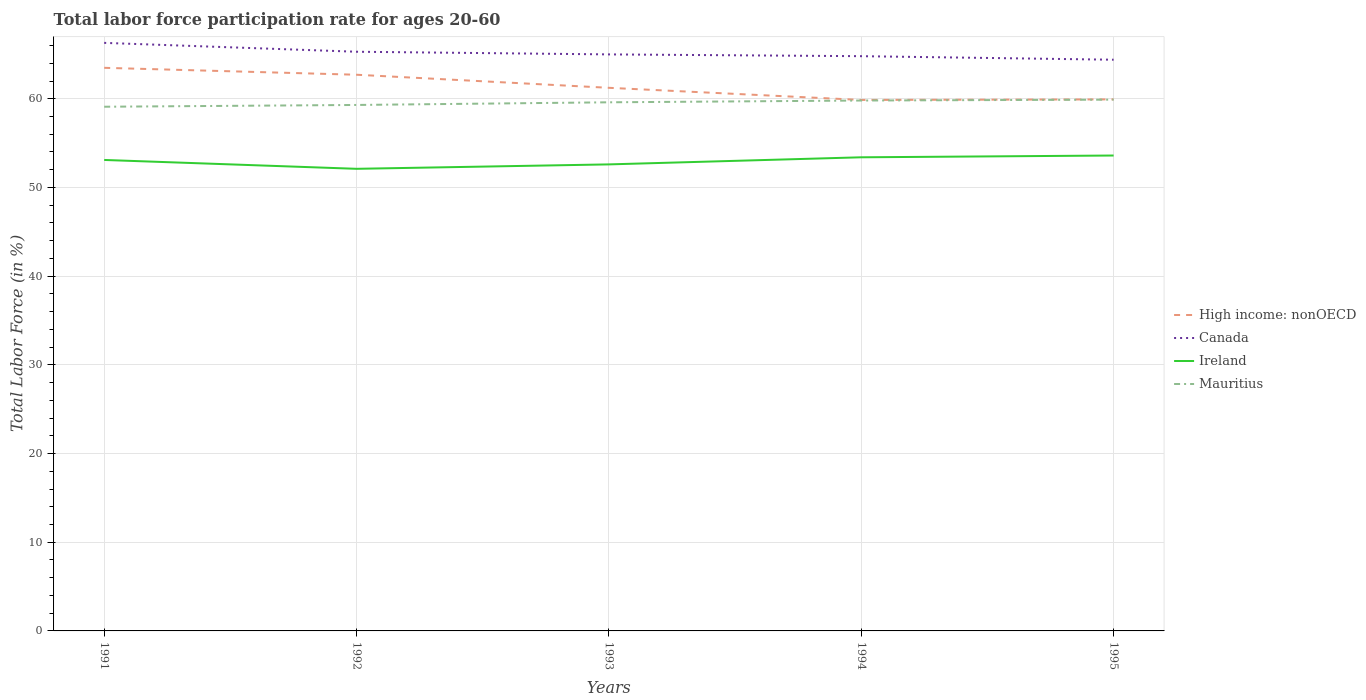How many different coloured lines are there?
Your answer should be compact. 4. Does the line corresponding to Mauritius intersect with the line corresponding to Ireland?
Offer a very short reply. No. Across all years, what is the maximum labor force participation rate in Canada?
Provide a short and direct response. 64.4. What is the total labor force participation rate in Mauritius in the graph?
Make the answer very short. -0.8. What is the difference between the highest and the second highest labor force participation rate in Canada?
Offer a terse response. 1.9. Is the labor force participation rate in Canada strictly greater than the labor force participation rate in Ireland over the years?
Your answer should be very brief. No. How many lines are there?
Keep it short and to the point. 4. What is the difference between two consecutive major ticks on the Y-axis?
Ensure brevity in your answer.  10. What is the title of the graph?
Provide a short and direct response. Total labor force participation rate for ages 20-60. What is the label or title of the X-axis?
Your response must be concise. Years. What is the label or title of the Y-axis?
Make the answer very short. Total Labor Force (in %). What is the Total Labor Force (in %) of High income: nonOECD in 1991?
Provide a succinct answer. 63.49. What is the Total Labor Force (in %) in Canada in 1991?
Make the answer very short. 66.3. What is the Total Labor Force (in %) in Ireland in 1991?
Your answer should be very brief. 53.1. What is the Total Labor Force (in %) in Mauritius in 1991?
Provide a short and direct response. 59.1. What is the Total Labor Force (in %) of High income: nonOECD in 1992?
Give a very brief answer. 62.71. What is the Total Labor Force (in %) in Canada in 1992?
Your response must be concise. 65.3. What is the Total Labor Force (in %) of Ireland in 1992?
Give a very brief answer. 52.1. What is the Total Labor Force (in %) in Mauritius in 1992?
Your response must be concise. 59.3. What is the Total Labor Force (in %) in High income: nonOECD in 1993?
Keep it short and to the point. 61.23. What is the Total Labor Force (in %) in Ireland in 1993?
Your answer should be compact. 52.6. What is the Total Labor Force (in %) of Mauritius in 1993?
Give a very brief answer. 59.6. What is the Total Labor Force (in %) of High income: nonOECD in 1994?
Your answer should be very brief. 59.87. What is the Total Labor Force (in %) in Canada in 1994?
Give a very brief answer. 64.8. What is the Total Labor Force (in %) in Ireland in 1994?
Provide a short and direct response. 53.4. What is the Total Labor Force (in %) of Mauritius in 1994?
Ensure brevity in your answer.  59.8. What is the Total Labor Force (in %) in High income: nonOECD in 1995?
Your answer should be very brief. 59.93. What is the Total Labor Force (in %) in Canada in 1995?
Provide a short and direct response. 64.4. What is the Total Labor Force (in %) of Ireland in 1995?
Keep it short and to the point. 53.6. What is the Total Labor Force (in %) in Mauritius in 1995?
Give a very brief answer. 59.9. Across all years, what is the maximum Total Labor Force (in %) in High income: nonOECD?
Make the answer very short. 63.49. Across all years, what is the maximum Total Labor Force (in %) of Canada?
Ensure brevity in your answer.  66.3. Across all years, what is the maximum Total Labor Force (in %) in Ireland?
Your response must be concise. 53.6. Across all years, what is the maximum Total Labor Force (in %) of Mauritius?
Your answer should be very brief. 59.9. Across all years, what is the minimum Total Labor Force (in %) of High income: nonOECD?
Make the answer very short. 59.87. Across all years, what is the minimum Total Labor Force (in %) of Canada?
Provide a succinct answer. 64.4. Across all years, what is the minimum Total Labor Force (in %) of Ireland?
Offer a terse response. 52.1. Across all years, what is the minimum Total Labor Force (in %) in Mauritius?
Give a very brief answer. 59.1. What is the total Total Labor Force (in %) of High income: nonOECD in the graph?
Make the answer very short. 307.22. What is the total Total Labor Force (in %) in Canada in the graph?
Offer a terse response. 325.8. What is the total Total Labor Force (in %) of Ireland in the graph?
Make the answer very short. 264.8. What is the total Total Labor Force (in %) in Mauritius in the graph?
Your answer should be very brief. 297.7. What is the difference between the Total Labor Force (in %) of High income: nonOECD in 1991 and that in 1992?
Keep it short and to the point. 0.78. What is the difference between the Total Labor Force (in %) of Canada in 1991 and that in 1992?
Your answer should be very brief. 1. What is the difference between the Total Labor Force (in %) in Ireland in 1991 and that in 1992?
Ensure brevity in your answer.  1. What is the difference between the Total Labor Force (in %) in Mauritius in 1991 and that in 1992?
Your answer should be very brief. -0.2. What is the difference between the Total Labor Force (in %) of High income: nonOECD in 1991 and that in 1993?
Provide a succinct answer. 2.25. What is the difference between the Total Labor Force (in %) in Ireland in 1991 and that in 1993?
Provide a short and direct response. 0.5. What is the difference between the Total Labor Force (in %) of Mauritius in 1991 and that in 1993?
Your answer should be compact. -0.5. What is the difference between the Total Labor Force (in %) in High income: nonOECD in 1991 and that in 1994?
Provide a succinct answer. 3.62. What is the difference between the Total Labor Force (in %) in Canada in 1991 and that in 1994?
Provide a short and direct response. 1.5. What is the difference between the Total Labor Force (in %) in Mauritius in 1991 and that in 1994?
Offer a terse response. -0.7. What is the difference between the Total Labor Force (in %) of High income: nonOECD in 1991 and that in 1995?
Provide a short and direct response. 3.56. What is the difference between the Total Labor Force (in %) of Canada in 1991 and that in 1995?
Provide a short and direct response. 1.9. What is the difference between the Total Labor Force (in %) in Ireland in 1991 and that in 1995?
Provide a short and direct response. -0.5. What is the difference between the Total Labor Force (in %) in High income: nonOECD in 1992 and that in 1993?
Your answer should be very brief. 1.47. What is the difference between the Total Labor Force (in %) of Canada in 1992 and that in 1993?
Offer a very short reply. 0.3. What is the difference between the Total Labor Force (in %) in Mauritius in 1992 and that in 1993?
Give a very brief answer. -0.3. What is the difference between the Total Labor Force (in %) of High income: nonOECD in 1992 and that in 1994?
Ensure brevity in your answer.  2.84. What is the difference between the Total Labor Force (in %) of Ireland in 1992 and that in 1994?
Your answer should be very brief. -1.3. What is the difference between the Total Labor Force (in %) in High income: nonOECD in 1992 and that in 1995?
Provide a short and direct response. 2.78. What is the difference between the Total Labor Force (in %) of Canada in 1992 and that in 1995?
Offer a very short reply. 0.9. What is the difference between the Total Labor Force (in %) of Mauritius in 1992 and that in 1995?
Give a very brief answer. -0.6. What is the difference between the Total Labor Force (in %) of High income: nonOECD in 1993 and that in 1994?
Provide a short and direct response. 1.37. What is the difference between the Total Labor Force (in %) in Ireland in 1993 and that in 1994?
Your response must be concise. -0.8. What is the difference between the Total Labor Force (in %) of Mauritius in 1993 and that in 1994?
Keep it short and to the point. -0.2. What is the difference between the Total Labor Force (in %) of High income: nonOECD in 1993 and that in 1995?
Give a very brief answer. 1.3. What is the difference between the Total Labor Force (in %) in Ireland in 1993 and that in 1995?
Your answer should be very brief. -1. What is the difference between the Total Labor Force (in %) of Mauritius in 1993 and that in 1995?
Provide a succinct answer. -0.3. What is the difference between the Total Labor Force (in %) of High income: nonOECD in 1994 and that in 1995?
Give a very brief answer. -0.06. What is the difference between the Total Labor Force (in %) in Mauritius in 1994 and that in 1995?
Keep it short and to the point. -0.1. What is the difference between the Total Labor Force (in %) in High income: nonOECD in 1991 and the Total Labor Force (in %) in Canada in 1992?
Provide a short and direct response. -1.81. What is the difference between the Total Labor Force (in %) in High income: nonOECD in 1991 and the Total Labor Force (in %) in Ireland in 1992?
Provide a short and direct response. 11.39. What is the difference between the Total Labor Force (in %) of High income: nonOECD in 1991 and the Total Labor Force (in %) of Mauritius in 1992?
Ensure brevity in your answer.  4.19. What is the difference between the Total Labor Force (in %) of Canada in 1991 and the Total Labor Force (in %) of Ireland in 1992?
Keep it short and to the point. 14.2. What is the difference between the Total Labor Force (in %) in Canada in 1991 and the Total Labor Force (in %) in Mauritius in 1992?
Offer a very short reply. 7. What is the difference between the Total Labor Force (in %) in High income: nonOECD in 1991 and the Total Labor Force (in %) in Canada in 1993?
Ensure brevity in your answer.  -1.51. What is the difference between the Total Labor Force (in %) in High income: nonOECD in 1991 and the Total Labor Force (in %) in Ireland in 1993?
Your answer should be compact. 10.89. What is the difference between the Total Labor Force (in %) in High income: nonOECD in 1991 and the Total Labor Force (in %) in Mauritius in 1993?
Provide a succinct answer. 3.89. What is the difference between the Total Labor Force (in %) of Canada in 1991 and the Total Labor Force (in %) of Mauritius in 1993?
Offer a very short reply. 6.7. What is the difference between the Total Labor Force (in %) in High income: nonOECD in 1991 and the Total Labor Force (in %) in Canada in 1994?
Your answer should be compact. -1.31. What is the difference between the Total Labor Force (in %) of High income: nonOECD in 1991 and the Total Labor Force (in %) of Ireland in 1994?
Your answer should be compact. 10.09. What is the difference between the Total Labor Force (in %) in High income: nonOECD in 1991 and the Total Labor Force (in %) in Mauritius in 1994?
Give a very brief answer. 3.69. What is the difference between the Total Labor Force (in %) in Canada in 1991 and the Total Labor Force (in %) in Ireland in 1994?
Provide a succinct answer. 12.9. What is the difference between the Total Labor Force (in %) in Canada in 1991 and the Total Labor Force (in %) in Mauritius in 1994?
Make the answer very short. 6.5. What is the difference between the Total Labor Force (in %) in Ireland in 1991 and the Total Labor Force (in %) in Mauritius in 1994?
Your answer should be compact. -6.7. What is the difference between the Total Labor Force (in %) of High income: nonOECD in 1991 and the Total Labor Force (in %) of Canada in 1995?
Offer a very short reply. -0.91. What is the difference between the Total Labor Force (in %) in High income: nonOECD in 1991 and the Total Labor Force (in %) in Ireland in 1995?
Give a very brief answer. 9.89. What is the difference between the Total Labor Force (in %) in High income: nonOECD in 1991 and the Total Labor Force (in %) in Mauritius in 1995?
Your answer should be very brief. 3.59. What is the difference between the Total Labor Force (in %) of High income: nonOECD in 1992 and the Total Labor Force (in %) of Canada in 1993?
Your response must be concise. -2.29. What is the difference between the Total Labor Force (in %) of High income: nonOECD in 1992 and the Total Labor Force (in %) of Ireland in 1993?
Ensure brevity in your answer.  10.11. What is the difference between the Total Labor Force (in %) in High income: nonOECD in 1992 and the Total Labor Force (in %) in Mauritius in 1993?
Offer a terse response. 3.11. What is the difference between the Total Labor Force (in %) of Canada in 1992 and the Total Labor Force (in %) of Ireland in 1993?
Offer a terse response. 12.7. What is the difference between the Total Labor Force (in %) of Ireland in 1992 and the Total Labor Force (in %) of Mauritius in 1993?
Provide a succinct answer. -7.5. What is the difference between the Total Labor Force (in %) of High income: nonOECD in 1992 and the Total Labor Force (in %) of Canada in 1994?
Provide a short and direct response. -2.09. What is the difference between the Total Labor Force (in %) in High income: nonOECD in 1992 and the Total Labor Force (in %) in Ireland in 1994?
Ensure brevity in your answer.  9.31. What is the difference between the Total Labor Force (in %) of High income: nonOECD in 1992 and the Total Labor Force (in %) of Mauritius in 1994?
Your answer should be compact. 2.91. What is the difference between the Total Labor Force (in %) of Canada in 1992 and the Total Labor Force (in %) of Ireland in 1994?
Offer a terse response. 11.9. What is the difference between the Total Labor Force (in %) in High income: nonOECD in 1992 and the Total Labor Force (in %) in Canada in 1995?
Ensure brevity in your answer.  -1.69. What is the difference between the Total Labor Force (in %) in High income: nonOECD in 1992 and the Total Labor Force (in %) in Ireland in 1995?
Your response must be concise. 9.11. What is the difference between the Total Labor Force (in %) in High income: nonOECD in 1992 and the Total Labor Force (in %) in Mauritius in 1995?
Your answer should be very brief. 2.81. What is the difference between the Total Labor Force (in %) in Canada in 1992 and the Total Labor Force (in %) in Ireland in 1995?
Ensure brevity in your answer.  11.7. What is the difference between the Total Labor Force (in %) in Canada in 1992 and the Total Labor Force (in %) in Mauritius in 1995?
Your answer should be very brief. 5.4. What is the difference between the Total Labor Force (in %) in High income: nonOECD in 1993 and the Total Labor Force (in %) in Canada in 1994?
Provide a short and direct response. -3.57. What is the difference between the Total Labor Force (in %) in High income: nonOECD in 1993 and the Total Labor Force (in %) in Ireland in 1994?
Give a very brief answer. 7.83. What is the difference between the Total Labor Force (in %) of High income: nonOECD in 1993 and the Total Labor Force (in %) of Mauritius in 1994?
Your answer should be very brief. 1.43. What is the difference between the Total Labor Force (in %) of Canada in 1993 and the Total Labor Force (in %) of Mauritius in 1994?
Keep it short and to the point. 5.2. What is the difference between the Total Labor Force (in %) in High income: nonOECD in 1993 and the Total Labor Force (in %) in Canada in 1995?
Your answer should be compact. -3.17. What is the difference between the Total Labor Force (in %) of High income: nonOECD in 1993 and the Total Labor Force (in %) of Ireland in 1995?
Provide a short and direct response. 7.63. What is the difference between the Total Labor Force (in %) of High income: nonOECD in 1993 and the Total Labor Force (in %) of Mauritius in 1995?
Your response must be concise. 1.33. What is the difference between the Total Labor Force (in %) in Canada in 1993 and the Total Labor Force (in %) in Mauritius in 1995?
Your response must be concise. 5.1. What is the difference between the Total Labor Force (in %) of Ireland in 1993 and the Total Labor Force (in %) of Mauritius in 1995?
Offer a terse response. -7.3. What is the difference between the Total Labor Force (in %) in High income: nonOECD in 1994 and the Total Labor Force (in %) in Canada in 1995?
Offer a very short reply. -4.53. What is the difference between the Total Labor Force (in %) of High income: nonOECD in 1994 and the Total Labor Force (in %) of Ireland in 1995?
Offer a very short reply. 6.27. What is the difference between the Total Labor Force (in %) in High income: nonOECD in 1994 and the Total Labor Force (in %) in Mauritius in 1995?
Your answer should be very brief. -0.03. What is the difference between the Total Labor Force (in %) of Canada in 1994 and the Total Labor Force (in %) of Ireland in 1995?
Ensure brevity in your answer.  11.2. What is the difference between the Total Labor Force (in %) in Canada in 1994 and the Total Labor Force (in %) in Mauritius in 1995?
Offer a very short reply. 4.9. What is the difference between the Total Labor Force (in %) in Ireland in 1994 and the Total Labor Force (in %) in Mauritius in 1995?
Give a very brief answer. -6.5. What is the average Total Labor Force (in %) in High income: nonOECD per year?
Your response must be concise. 61.44. What is the average Total Labor Force (in %) of Canada per year?
Ensure brevity in your answer.  65.16. What is the average Total Labor Force (in %) in Ireland per year?
Provide a short and direct response. 52.96. What is the average Total Labor Force (in %) of Mauritius per year?
Provide a succinct answer. 59.54. In the year 1991, what is the difference between the Total Labor Force (in %) of High income: nonOECD and Total Labor Force (in %) of Canada?
Give a very brief answer. -2.81. In the year 1991, what is the difference between the Total Labor Force (in %) in High income: nonOECD and Total Labor Force (in %) in Ireland?
Your response must be concise. 10.39. In the year 1991, what is the difference between the Total Labor Force (in %) in High income: nonOECD and Total Labor Force (in %) in Mauritius?
Offer a terse response. 4.39. In the year 1991, what is the difference between the Total Labor Force (in %) in Canada and Total Labor Force (in %) in Mauritius?
Offer a very short reply. 7.2. In the year 1992, what is the difference between the Total Labor Force (in %) of High income: nonOECD and Total Labor Force (in %) of Canada?
Make the answer very short. -2.59. In the year 1992, what is the difference between the Total Labor Force (in %) of High income: nonOECD and Total Labor Force (in %) of Ireland?
Your answer should be very brief. 10.61. In the year 1992, what is the difference between the Total Labor Force (in %) of High income: nonOECD and Total Labor Force (in %) of Mauritius?
Offer a very short reply. 3.41. In the year 1992, what is the difference between the Total Labor Force (in %) of Canada and Total Labor Force (in %) of Ireland?
Offer a very short reply. 13.2. In the year 1992, what is the difference between the Total Labor Force (in %) in Ireland and Total Labor Force (in %) in Mauritius?
Make the answer very short. -7.2. In the year 1993, what is the difference between the Total Labor Force (in %) of High income: nonOECD and Total Labor Force (in %) of Canada?
Provide a short and direct response. -3.77. In the year 1993, what is the difference between the Total Labor Force (in %) of High income: nonOECD and Total Labor Force (in %) of Ireland?
Provide a succinct answer. 8.63. In the year 1993, what is the difference between the Total Labor Force (in %) in High income: nonOECD and Total Labor Force (in %) in Mauritius?
Ensure brevity in your answer.  1.63. In the year 1993, what is the difference between the Total Labor Force (in %) in Ireland and Total Labor Force (in %) in Mauritius?
Your answer should be very brief. -7. In the year 1994, what is the difference between the Total Labor Force (in %) of High income: nonOECD and Total Labor Force (in %) of Canada?
Give a very brief answer. -4.93. In the year 1994, what is the difference between the Total Labor Force (in %) in High income: nonOECD and Total Labor Force (in %) in Ireland?
Your answer should be very brief. 6.47. In the year 1994, what is the difference between the Total Labor Force (in %) of High income: nonOECD and Total Labor Force (in %) of Mauritius?
Offer a terse response. 0.07. In the year 1994, what is the difference between the Total Labor Force (in %) in Canada and Total Labor Force (in %) in Ireland?
Offer a very short reply. 11.4. In the year 1994, what is the difference between the Total Labor Force (in %) of Ireland and Total Labor Force (in %) of Mauritius?
Your response must be concise. -6.4. In the year 1995, what is the difference between the Total Labor Force (in %) of High income: nonOECD and Total Labor Force (in %) of Canada?
Your answer should be compact. -4.47. In the year 1995, what is the difference between the Total Labor Force (in %) of High income: nonOECD and Total Labor Force (in %) of Ireland?
Your answer should be very brief. 6.33. In the year 1995, what is the difference between the Total Labor Force (in %) in High income: nonOECD and Total Labor Force (in %) in Mauritius?
Offer a terse response. 0.03. In the year 1995, what is the difference between the Total Labor Force (in %) in Canada and Total Labor Force (in %) in Ireland?
Your response must be concise. 10.8. In the year 1995, what is the difference between the Total Labor Force (in %) of Canada and Total Labor Force (in %) of Mauritius?
Provide a succinct answer. 4.5. What is the ratio of the Total Labor Force (in %) of High income: nonOECD in 1991 to that in 1992?
Ensure brevity in your answer.  1.01. What is the ratio of the Total Labor Force (in %) of Canada in 1991 to that in 1992?
Your answer should be very brief. 1.02. What is the ratio of the Total Labor Force (in %) of Ireland in 1991 to that in 1992?
Your answer should be compact. 1.02. What is the ratio of the Total Labor Force (in %) in High income: nonOECD in 1991 to that in 1993?
Make the answer very short. 1.04. What is the ratio of the Total Labor Force (in %) of Ireland in 1991 to that in 1993?
Provide a succinct answer. 1.01. What is the ratio of the Total Labor Force (in %) of Mauritius in 1991 to that in 1993?
Give a very brief answer. 0.99. What is the ratio of the Total Labor Force (in %) in High income: nonOECD in 1991 to that in 1994?
Keep it short and to the point. 1.06. What is the ratio of the Total Labor Force (in %) in Canada in 1991 to that in 1994?
Offer a very short reply. 1.02. What is the ratio of the Total Labor Force (in %) of Mauritius in 1991 to that in 1994?
Your answer should be very brief. 0.99. What is the ratio of the Total Labor Force (in %) in High income: nonOECD in 1991 to that in 1995?
Your response must be concise. 1.06. What is the ratio of the Total Labor Force (in %) of Canada in 1991 to that in 1995?
Your answer should be very brief. 1.03. What is the ratio of the Total Labor Force (in %) in Ireland in 1991 to that in 1995?
Keep it short and to the point. 0.99. What is the ratio of the Total Labor Force (in %) of Mauritius in 1991 to that in 1995?
Give a very brief answer. 0.99. What is the ratio of the Total Labor Force (in %) of High income: nonOECD in 1992 to that in 1993?
Your response must be concise. 1.02. What is the ratio of the Total Labor Force (in %) of Canada in 1992 to that in 1993?
Your answer should be compact. 1. What is the ratio of the Total Labor Force (in %) in Ireland in 1992 to that in 1993?
Your answer should be very brief. 0.99. What is the ratio of the Total Labor Force (in %) in High income: nonOECD in 1992 to that in 1994?
Provide a short and direct response. 1.05. What is the ratio of the Total Labor Force (in %) of Canada in 1992 to that in 1994?
Provide a succinct answer. 1.01. What is the ratio of the Total Labor Force (in %) in Ireland in 1992 to that in 1994?
Provide a succinct answer. 0.98. What is the ratio of the Total Labor Force (in %) in High income: nonOECD in 1992 to that in 1995?
Provide a succinct answer. 1.05. What is the ratio of the Total Labor Force (in %) in Canada in 1992 to that in 1995?
Offer a terse response. 1.01. What is the ratio of the Total Labor Force (in %) of Ireland in 1992 to that in 1995?
Provide a short and direct response. 0.97. What is the ratio of the Total Labor Force (in %) in Mauritius in 1992 to that in 1995?
Give a very brief answer. 0.99. What is the ratio of the Total Labor Force (in %) of High income: nonOECD in 1993 to that in 1994?
Provide a succinct answer. 1.02. What is the ratio of the Total Labor Force (in %) in Canada in 1993 to that in 1994?
Keep it short and to the point. 1. What is the ratio of the Total Labor Force (in %) in Ireland in 1993 to that in 1994?
Your answer should be very brief. 0.98. What is the ratio of the Total Labor Force (in %) in Mauritius in 1993 to that in 1994?
Your answer should be compact. 1. What is the ratio of the Total Labor Force (in %) in High income: nonOECD in 1993 to that in 1995?
Your response must be concise. 1.02. What is the ratio of the Total Labor Force (in %) of Canada in 1993 to that in 1995?
Provide a short and direct response. 1.01. What is the ratio of the Total Labor Force (in %) in Ireland in 1993 to that in 1995?
Provide a short and direct response. 0.98. What is the ratio of the Total Labor Force (in %) of Mauritius in 1993 to that in 1995?
Ensure brevity in your answer.  0.99. What is the ratio of the Total Labor Force (in %) of Canada in 1994 to that in 1995?
Provide a short and direct response. 1.01. What is the difference between the highest and the second highest Total Labor Force (in %) in High income: nonOECD?
Give a very brief answer. 0.78. What is the difference between the highest and the second highest Total Labor Force (in %) of Ireland?
Your response must be concise. 0.2. What is the difference between the highest and the lowest Total Labor Force (in %) in High income: nonOECD?
Provide a succinct answer. 3.62. What is the difference between the highest and the lowest Total Labor Force (in %) in Mauritius?
Make the answer very short. 0.8. 